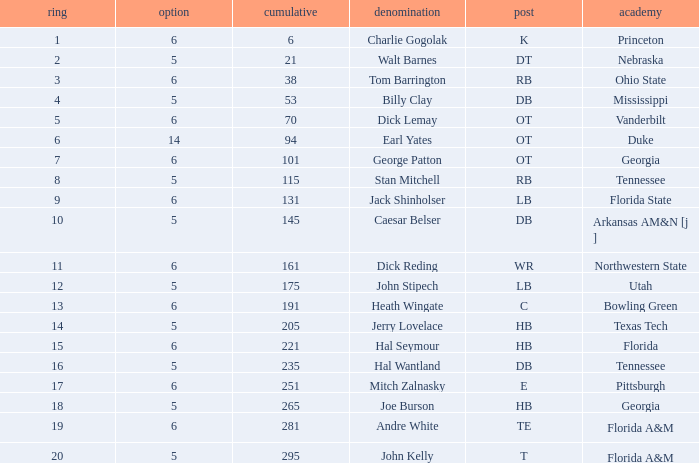What is the sum of Overall, when Pick is greater than 5, when Round is less than 11, and when Name is "Tom Barrington"? 38.0. 